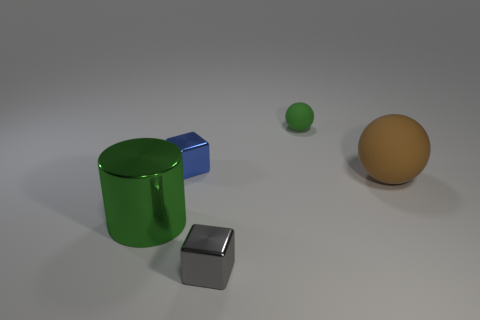Can you estimate the sizes of the objects relative to each other? Certainly. The green rubber ball is the smallest object, the blue and grey cubes are intermediate in size with the grey one being slightly smaller, and the orange ball is the largest of the four. 